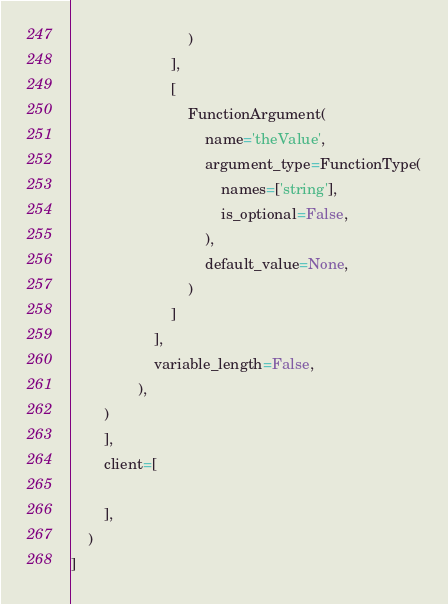Convert code to text. <code><loc_0><loc_0><loc_500><loc_500><_Python_>                            )
                        ],
                        [
                            FunctionArgument(
                                name='theValue',
                                argument_type=FunctionType(
                                    names=['string'],
                                    is_optional=False,
                                ),
                                default_value=None,
                            )
                        ]
                    ],
                    variable_length=False,
                ),
        )
        ],
        client=[
            
        ],
    )
]
</code> 